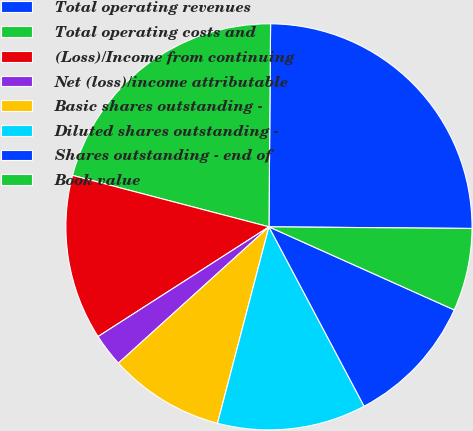Convert chart. <chart><loc_0><loc_0><loc_500><loc_500><pie_chart><fcel>Total operating revenues<fcel>Total operating costs and<fcel>(Loss)/Income from continuing<fcel>Net (loss)/income attributable<fcel>Basic shares outstanding -<fcel>Diluted shares outstanding -<fcel>Shares outstanding - end of<fcel>Book value<nl><fcel>25.0%<fcel>21.05%<fcel>13.16%<fcel>2.63%<fcel>9.21%<fcel>11.84%<fcel>10.53%<fcel>6.58%<nl></chart> 